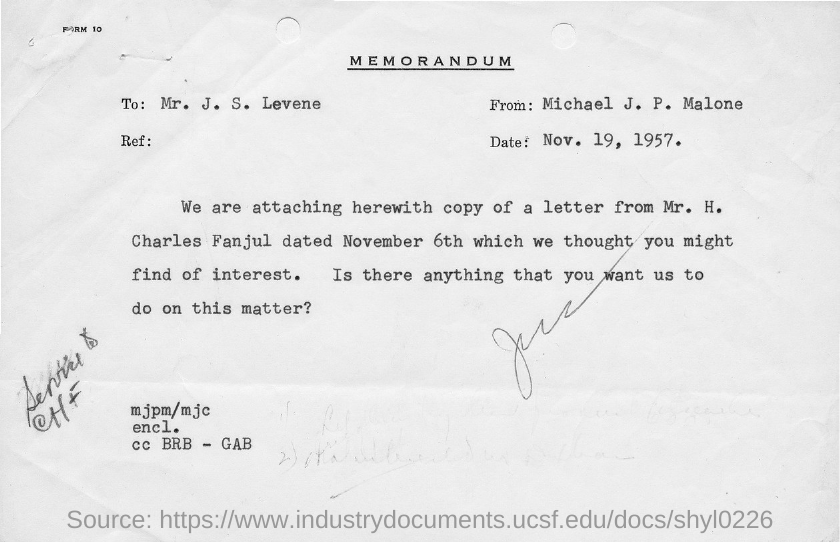What is the title of the document?
Your response must be concise. Memorandum. 